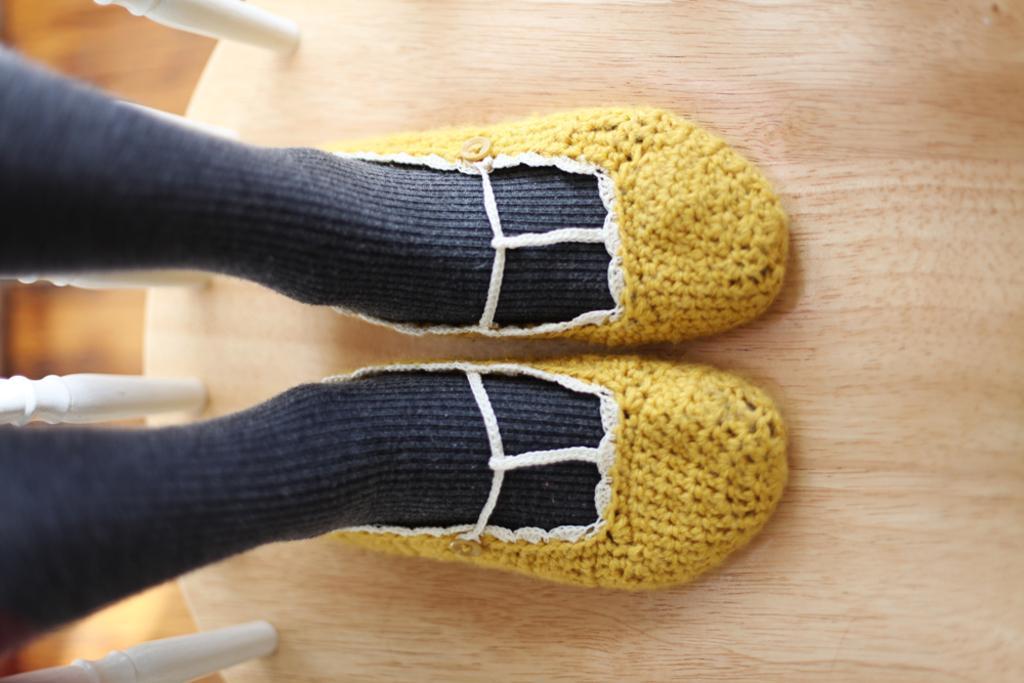Describe this image in one or two sentences. In this picture, we see the legs of a person wearing black socks and yellow shoes. These shoes are made up of wool. In the background, we see a wooden floor. 